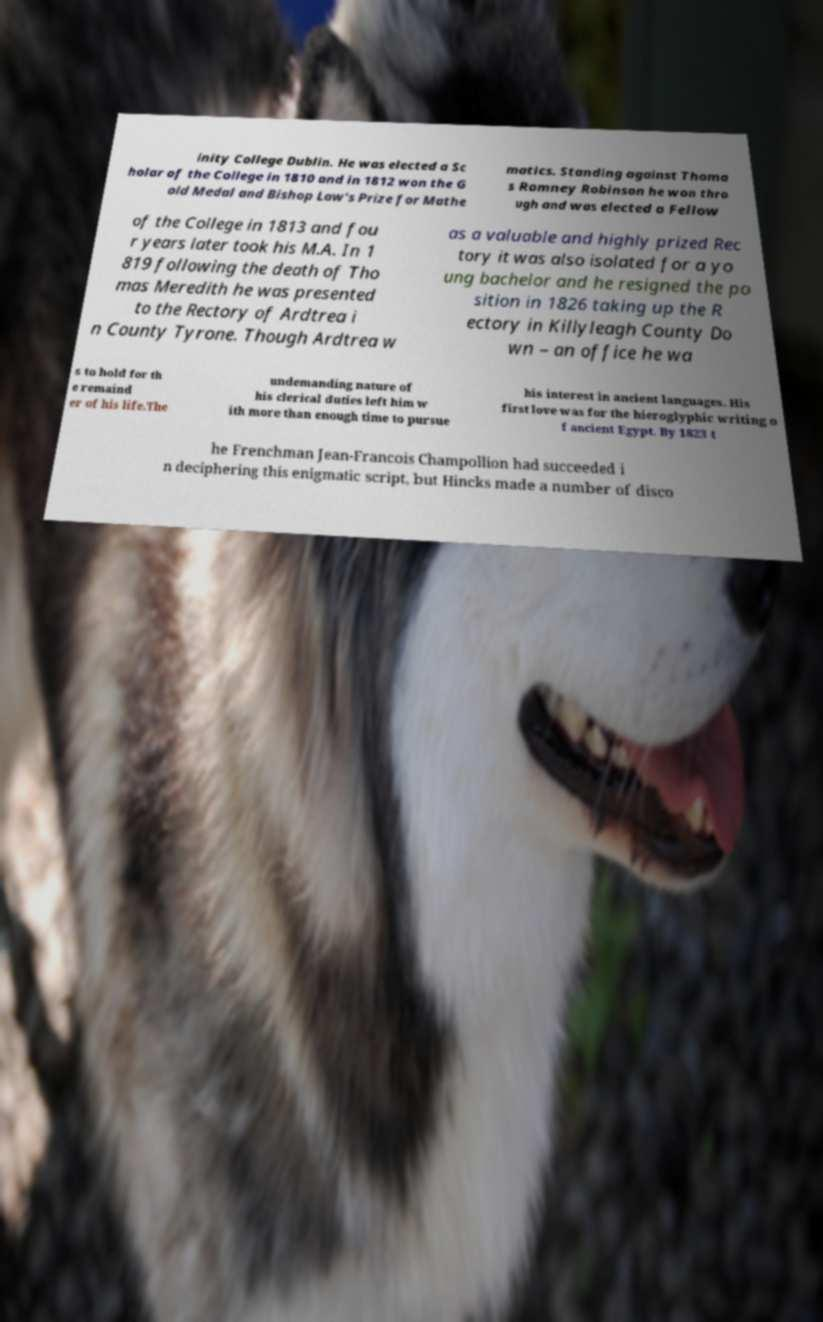Please identify and transcribe the text found in this image. inity College Dublin. He was elected a Sc holar of the College in 1810 and in 1812 won the G old Medal and Bishop Law's Prize for Mathe matics. Standing against Thoma s Romney Robinson he won thro ugh and was elected a Fellow of the College in 1813 and fou r years later took his M.A. In 1 819 following the death of Tho mas Meredith he was presented to the Rectory of Ardtrea i n County Tyrone. Though Ardtrea w as a valuable and highly prized Rec tory it was also isolated for a yo ung bachelor and he resigned the po sition in 1826 taking up the R ectory in Killyleagh County Do wn – an office he wa s to hold for th e remaind er of his life.The undemanding nature of his clerical duties left him w ith more than enough time to pursue his interest in ancient languages. His first love was for the hieroglyphic writing o f ancient Egypt. By 1823 t he Frenchman Jean-Francois Champollion had succeeded i n deciphering this enigmatic script, but Hincks made a number of disco 